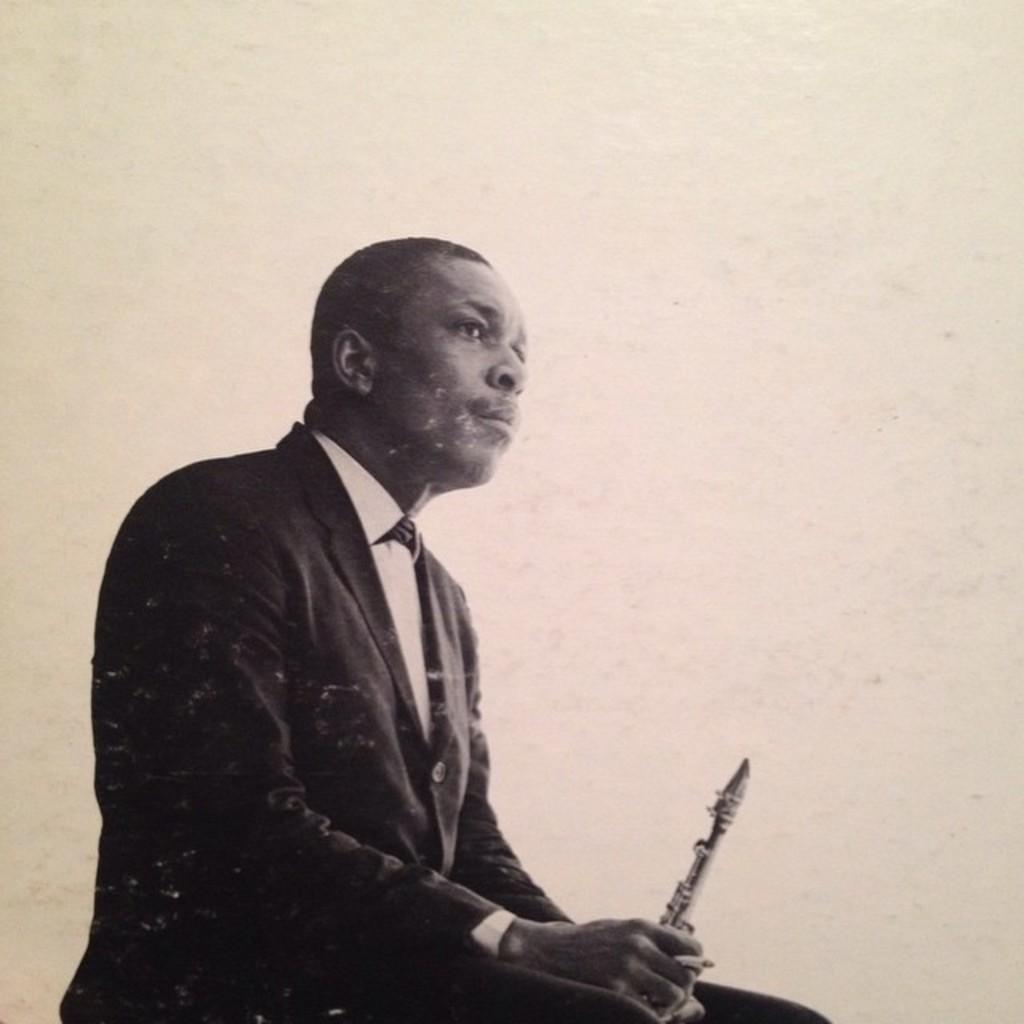What is the color scheme of the image? The image is black and white. What is the man in the image doing? The man is sitting in the image. What is the man holding in his hand? The man is holding an object in his hand. What can be seen in the man's finger? The man has a cigarette in his finger. How does the man in the image rub his eyes? There is no indication in the image that the man is rubbing his eyes. 